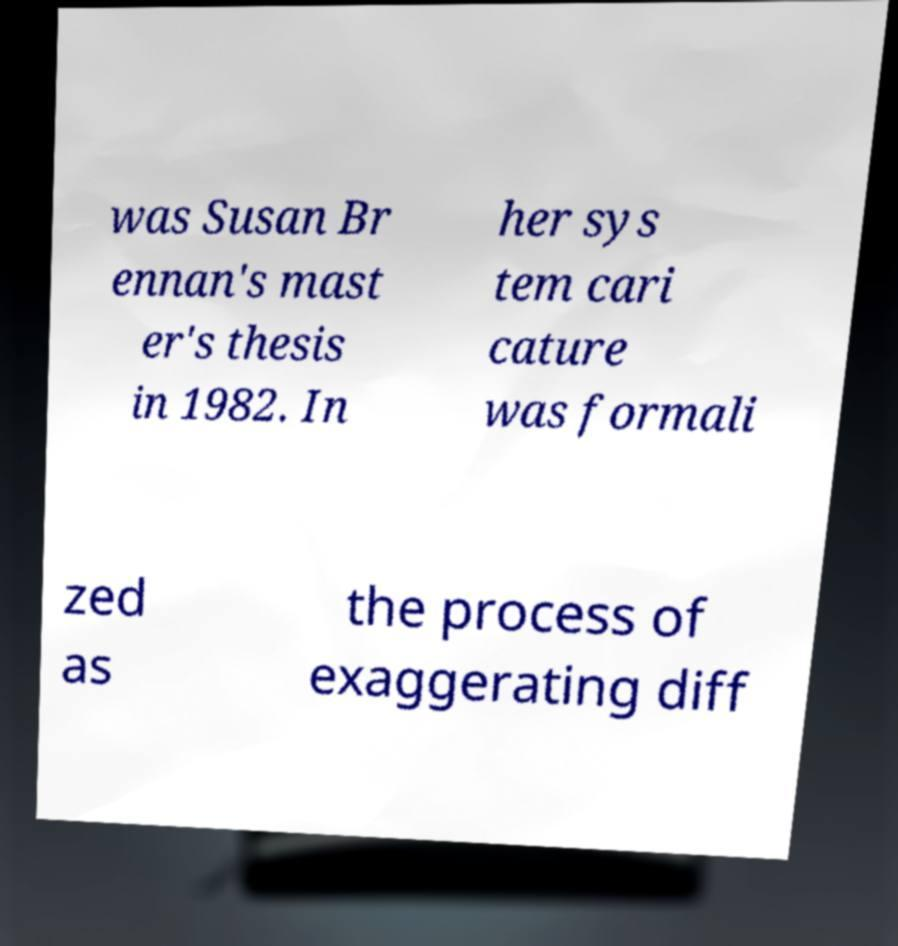Can you accurately transcribe the text from the provided image for me? was Susan Br ennan's mast er's thesis in 1982. In her sys tem cari cature was formali zed as the process of exaggerating diff 